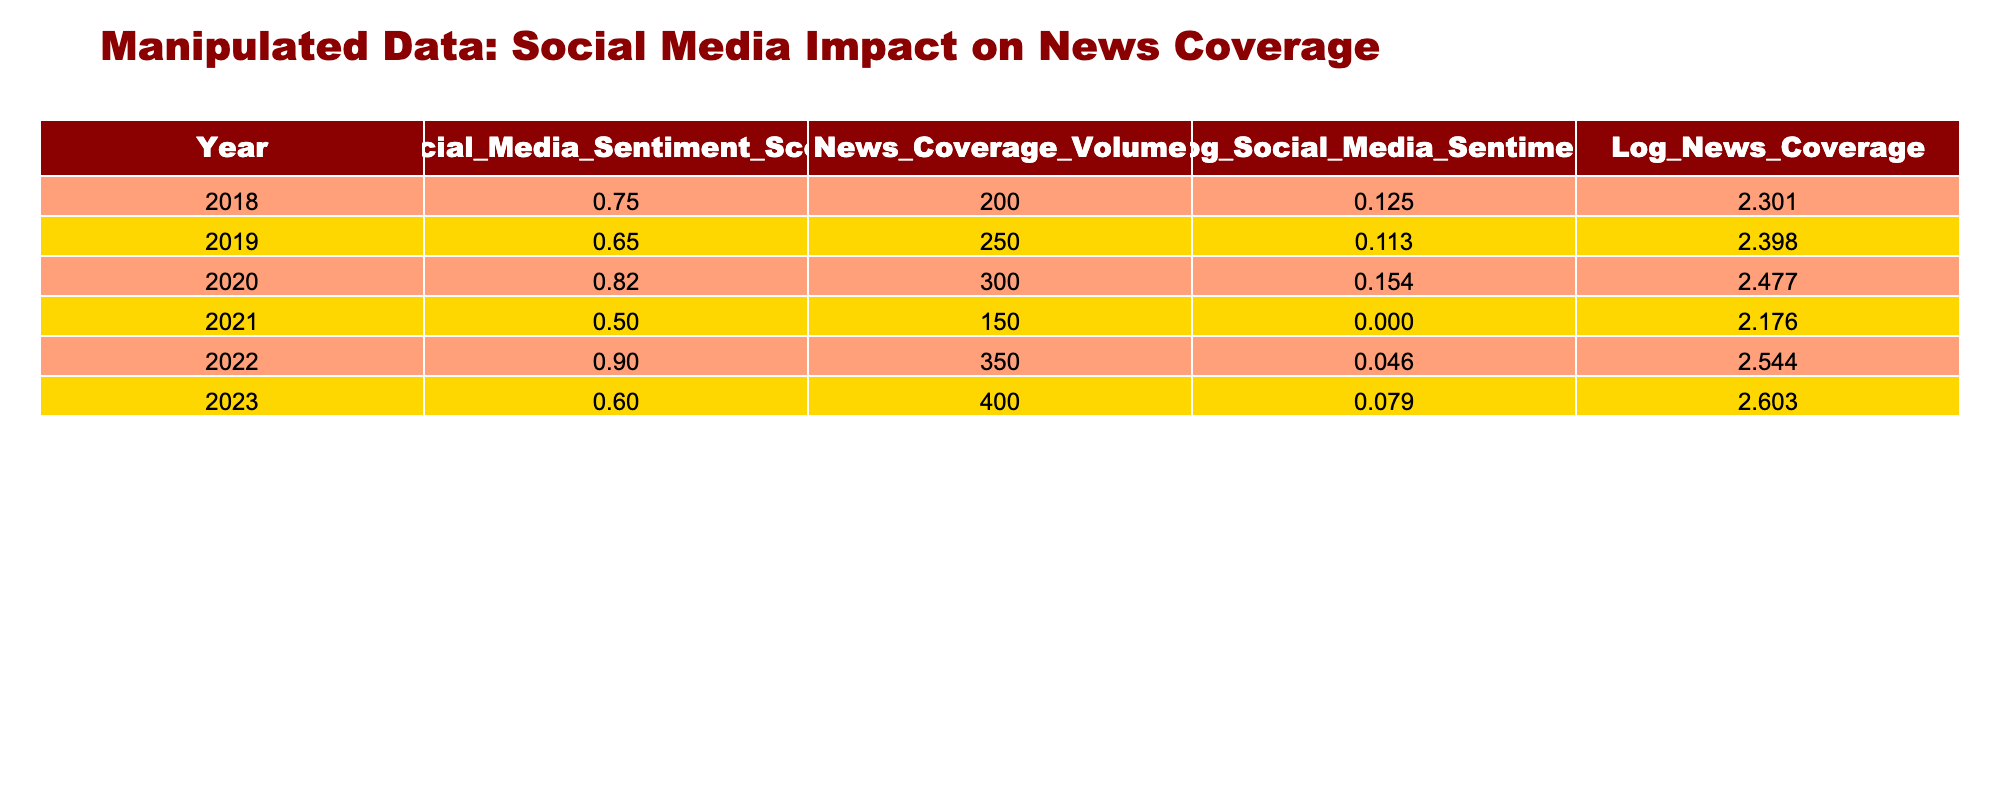What was the highest Social Media Sentiment Score recorded in the table? The Social Media Sentiment Score column shows the values for each year. Scanning through the values, the highest score is 0.90 recorded in 2022.
Answer: 0.90 What year had the lowest News Coverage Volume? Looking at the News Coverage Volume column, the year 2021 has the lowest value of 150.
Answer: 2021 What is the difference in Log_News_Coverage between 2020 and 2022? We need to subtract the Log_News_Coverage value of 2020 (2.477) from that of 2022 (2.544). The calculation is 2.544 - 2.477 = 0.067.
Answer: 0.067 Is the Social Media Sentiment Score in 2019 higher than that in 2023? The score for 2019 is 0.65 and for 2023 it is 0.60. Since 0.65 is higher than 0.60, the statement is true.
Answer: Yes What is the average Log_Social_Media_Sentiment for the years in the table? To find the average, we add the Log_Social_Media_Sentiment values: 0.125 + 0.113 + 0.154 + 0.000 + 0.046 + 0.079 = 0.517. Then we divide by the number of entries (6). The average is 0.517 / 6 = 0.0862.
Answer: 0.0862 Which year saw an increase in both Social Media Sentiment Score and News Coverage Volume compared to the previous year? By examining the rows, we can see that 2020 has a Social Media Sentiment Score of 0.82 (higher than 2019's 0.65) and News Coverage Volume of 300 (higher than 2019's 250). Hence, 2020 shows an increase in both metrics.
Answer: 2020 What is the total News Coverage Volume across all years? To find the total, we sum the News Coverage Volume values: 200 + 250 + 300 + 150 + 350 + 400 = 1650.
Answer: 1650 In how many years was the Log_Social_Media_Sentiment positive? The Log_Social_Media_Sentiment is a positive number for the years 2018, 2020, 2022, and 2023 (values 0.125, 0.154, 0.046, 0.079). Counting these, we see 4 years had positive values.
Answer: 4 